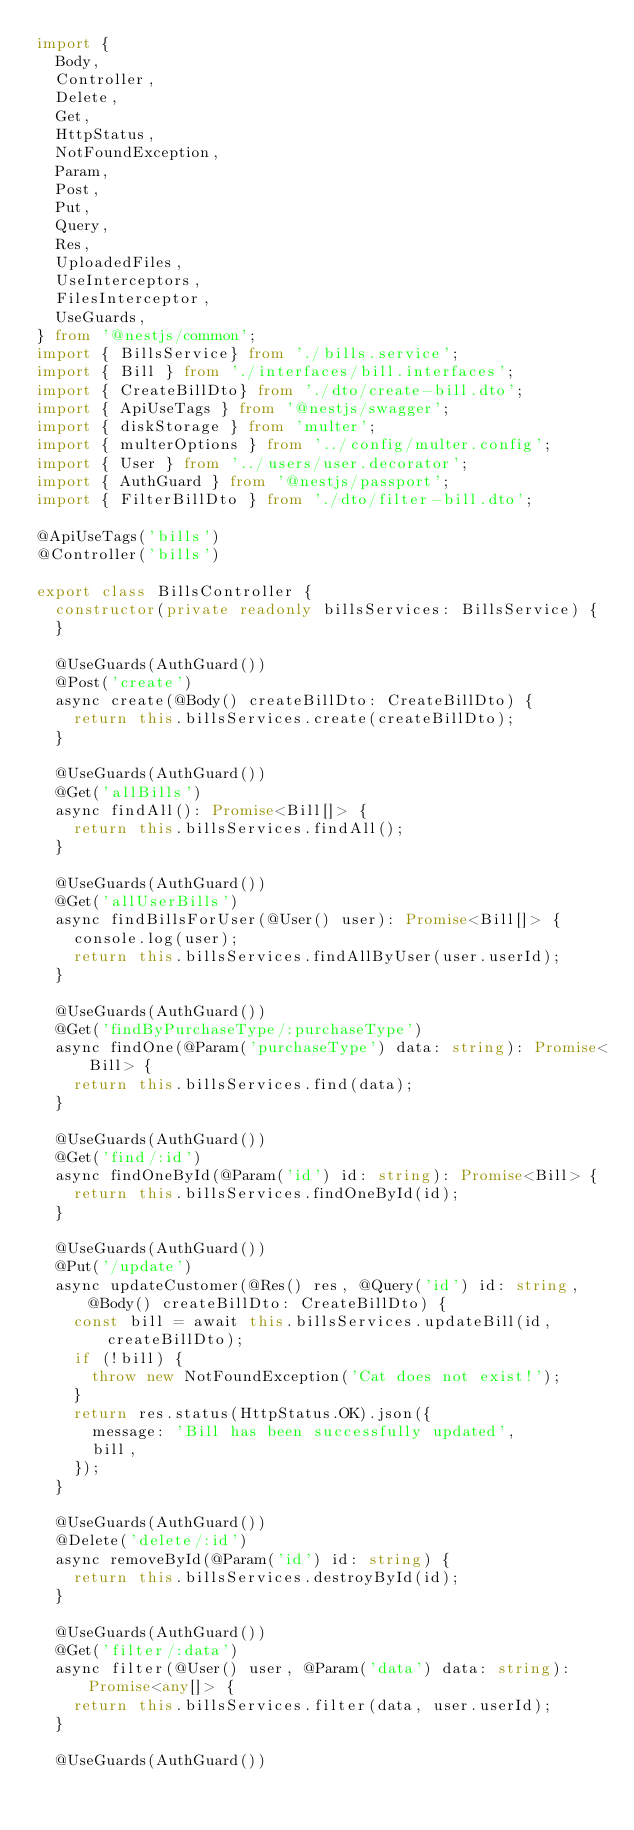Convert code to text. <code><loc_0><loc_0><loc_500><loc_500><_TypeScript_>import {
  Body,
  Controller,
  Delete,
  Get,
  HttpStatus,
  NotFoundException,
  Param,
  Post,
  Put,
  Query,
  Res,
  UploadedFiles,
  UseInterceptors,
  FilesInterceptor,
  UseGuards,
} from '@nestjs/common';
import { BillsService} from './bills.service';
import { Bill } from './interfaces/bill.interfaces';
import { CreateBillDto} from './dto/create-bill.dto';
import { ApiUseTags } from '@nestjs/swagger';
import { diskStorage } from 'multer';
import { multerOptions } from '../config/multer.config';
import { User } from '../users/user.decorator';
import { AuthGuard } from '@nestjs/passport';
import { FilterBillDto } from './dto/filter-bill.dto';

@ApiUseTags('bills')
@Controller('bills')

export class BillsController {
  constructor(private readonly billsServices: BillsService) {
  }

  @UseGuards(AuthGuard())
  @Post('create')
  async create(@Body() createBillDto: CreateBillDto) {
    return this.billsServices.create(createBillDto);
  }

  @UseGuards(AuthGuard())
  @Get('allBills')
  async findAll(): Promise<Bill[]> {
    return this.billsServices.findAll();
  }

  @UseGuards(AuthGuard())
  @Get('allUserBills')
  async findBillsForUser(@User() user): Promise<Bill[]> {
    console.log(user);
    return this.billsServices.findAllByUser(user.userId);
  }

  @UseGuards(AuthGuard())
  @Get('findByPurchaseType/:purchaseType')
  async findOne(@Param('purchaseType') data: string): Promise<Bill> {
    return this.billsServices.find(data);
  }

  @UseGuards(AuthGuard())
  @Get('find/:id')
  async findOneById(@Param('id') id: string): Promise<Bill> {
    return this.billsServices.findOneById(id);
  }

  @UseGuards(AuthGuard())
  @Put('/update')
  async updateCustomer(@Res() res, @Query('id') id: string, @Body() createBillDto: CreateBillDto) {
    const bill = await this.billsServices.updateBill(id, createBillDto);
    if (!bill) {
      throw new NotFoundException('Cat does not exist!');
    }
    return res.status(HttpStatus.OK).json({
      message: 'Bill has been successfully updated',
      bill,
    });
  }

  @UseGuards(AuthGuard())
  @Delete('delete/:id')
  async removeById(@Param('id') id: string) {
    return this.billsServices.destroyById(id);
  }

  @UseGuards(AuthGuard())
  @Get('filter/:data')
  async filter(@User() user, @Param('data') data: string): Promise<any[]> {
    return this.billsServices.filter(data, user.userId);
  }

  @UseGuards(AuthGuard())</code> 